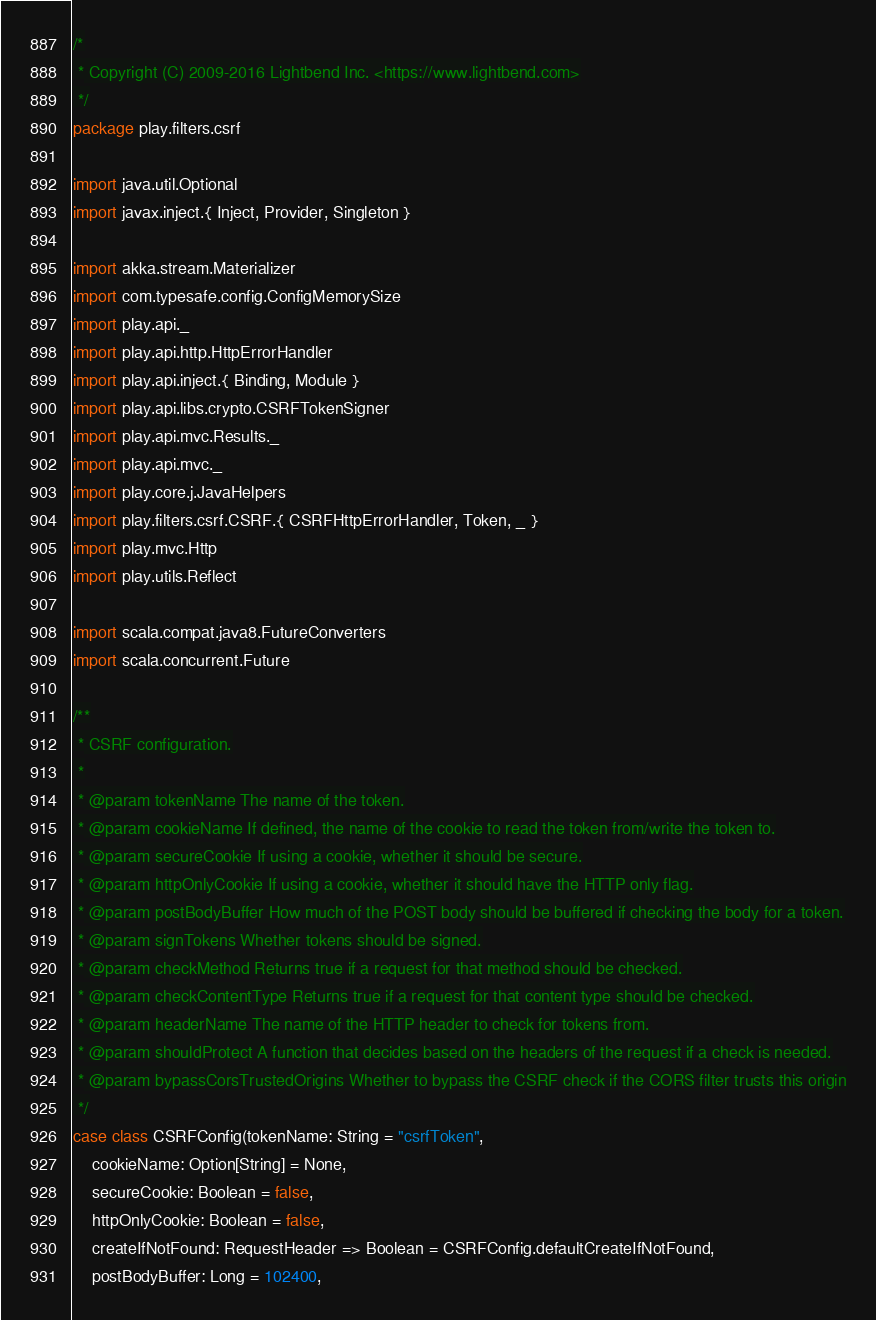<code> <loc_0><loc_0><loc_500><loc_500><_Scala_>/*
 * Copyright (C) 2009-2016 Lightbend Inc. <https://www.lightbend.com>
 */
package play.filters.csrf

import java.util.Optional
import javax.inject.{ Inject, Provider, Singleton }

import akka.stream.Materializer
import com.typesafe.config.ConfigMemorySize
import play.api._
import play.api.http.HttpErrorHandler
import play.api.inject.{ Binding, Module }
import play.api.libs.crypto.CSRFTokenSigner
import play.api.mvc.Results._
import play.api.mvc._
import play.core.j.JavaHelpers
import play.filters.csrf.CSRF.{ CSRFHttpErrorHandler, Token, _ }
import play.mvc.Http
import play.utils.Reflect

import scala.compat.java8.FutureConverters
import scala.concurrent.Future

/**
 * CSRF configuration.
 *
 * @param tokenName The name of the token.
 * @param cookieName If defined, the name of the cookie to read the token from/write the token to.
 * @param secureCookie If using a cookie, whether it should be secure.
 * @param httpOnlyCookie If using a cookie, whether it should have the HTTP only flag.
 * @param postBodyBuffer How much of the POST body should be buffered if checking the body for a token.
 * @param signTokens Whether tokens should be signed.
 * @param checkMethod Returns true if a request for that method should be checked.
 * @param checkContentType Returns true if a request for that content type should be checked.
 * @param headerName The name of the HTTP header to check for tokens from.
 * @param shouldProtect A function that decides based on the headers of the request if a check is needed.
 * @param bypassCorsTrustedOrigins Whether to bypass the CSRF check if the CORS filter trusts this origin
 */
case class CSRFConfig(tokenName: String = "csrfToken",
    cookieName: Option[String] = None,
    secureCookie: Boolean = false,
    httpOnlyCookie: Boolean = false,
    createIfNotFound: RequestHeader => Boolean = CSRFConfig.defaultCreateIfNotFound,
    postBodyBuffer: Long = 102400,</code> 